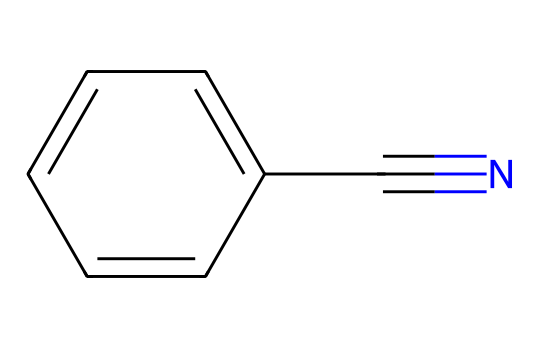What is the total number of carbon atoms in benzonitrile? The SMILES representation indicates there are six carbon atoms in the aromatic ring (c1ccccc1) and one carbon atom in the nitrile functional group (C#N), leading to a total of seven carbon atoms.
Answer: seven How many nitrogen atoms are present in the structure? The SMILES indicates the presence of one nitrogen atom in the nitrile group (C#N), so there is only one nitrogen atom in the entire structure.
Answer: one What type of functional group is found in benzonitrile? The C#N indicates the presence of a nitrile functional group, which is characteristic of compounds where a carbon is triple-bonded to a nitrogen.
Answer: nitrile What is the degree of unsaturation present in benzonitrile? The structure features one aromatic ring and the nitrile group. The presence of each double bond or ring contributes to the degree of unsaturation, summing to a total of 5 degrees of unsaturation (4 from the benzene and 1 from the nitrile group).
Answer: five What element is responsible for the cyanide functional behavior? The nitrile functional group (C#N) contains a carbon atom directly bonded to a nitrogen atom, making the nitrogen is responsible for the cyanide behavior of the compound.
Answer: nitrogen How many hydrogen atoms does benzonitrile contain? The benzene ring normally has six hydrogen atoms, but there is one hydrogen replaced by a nitrile group, resulting in a total of five hydrogen atoms remaining in benzonitrile.
Answer: five Is benzonitrile polar or nonpolar? The presence of the polar nitrile group (C#N) influences the overall polarity of the molecule, making benzonitrile a polar compound due to its asymmetric charge distribution.
Answer: polar 